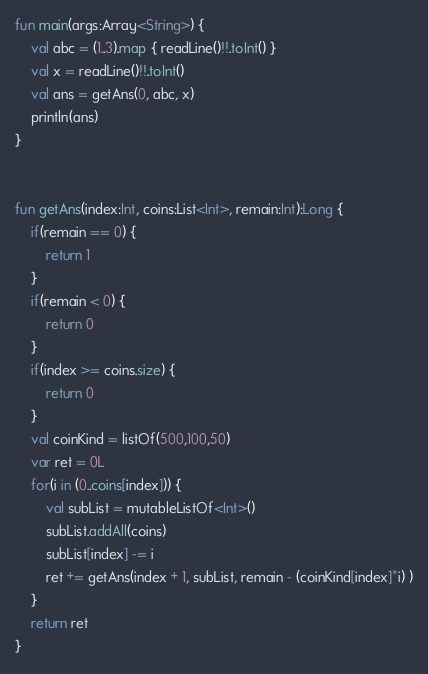Convert code to text. <code><loc_0><loc_0><loc_500><loc_500><_Kotlin_>fun main(args:Array<String>) {
    val abc = (1..3).map { readLine()!!.toInt() }
    val x = readLine()!!.toInt()
    val ans = getAns(0, abc, x)
    println(ans)
}


fun getAns(index:Int, coins:List<Int>, remain:Int):Long {
    if(remain == 0) {
        return 1
    }
    if(remain < 0) {
        return 0
    }
    if(index >= coins.size) {
        return 0
    }
    val coinKind = listOf(500,100,50)
    var ret = 0L
    for(i in (0..coins[index])) {
        val subList = mutableListOf<Int>()
        subList.addAll(coins)
        subList[index] -= i
        ret += getAns(index + 1, subList, remain - (coinKind[index]*i) )
    }
    return ret
}</code> 